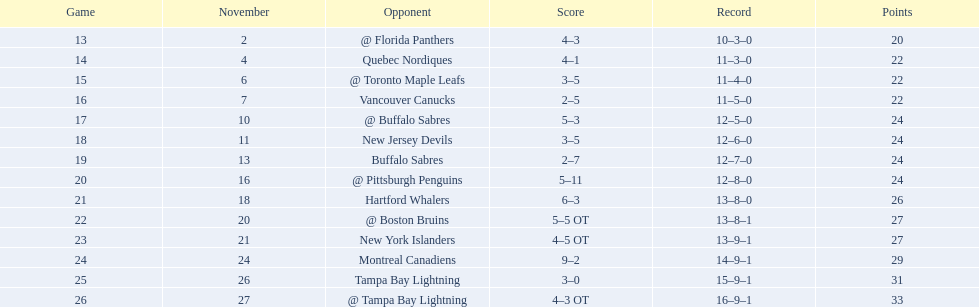How many continuous seasons did the flyers not participate in the playoffs until the 1993-1994 season? 5. 